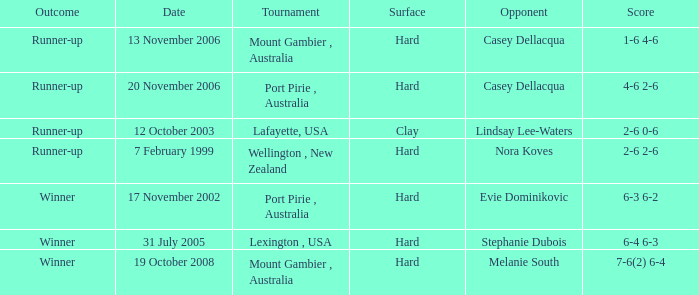Which Tournament has an Outcome of winner on 19 october 2008? Mount Gambier , Australia. 